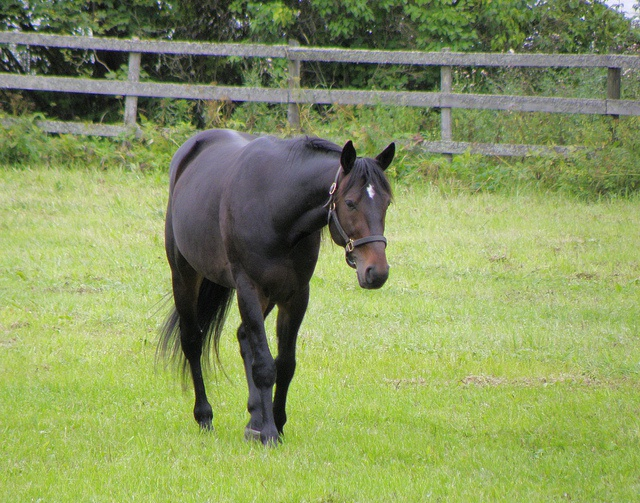Describe the objects in this image and their specific colors. I can see a horse in teal, black, gray, and olive tones in this image. 